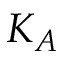Convert formula to latex. <formula><loc_0><loc_0><loc_500><loc_500>K _ { A }</formula> 